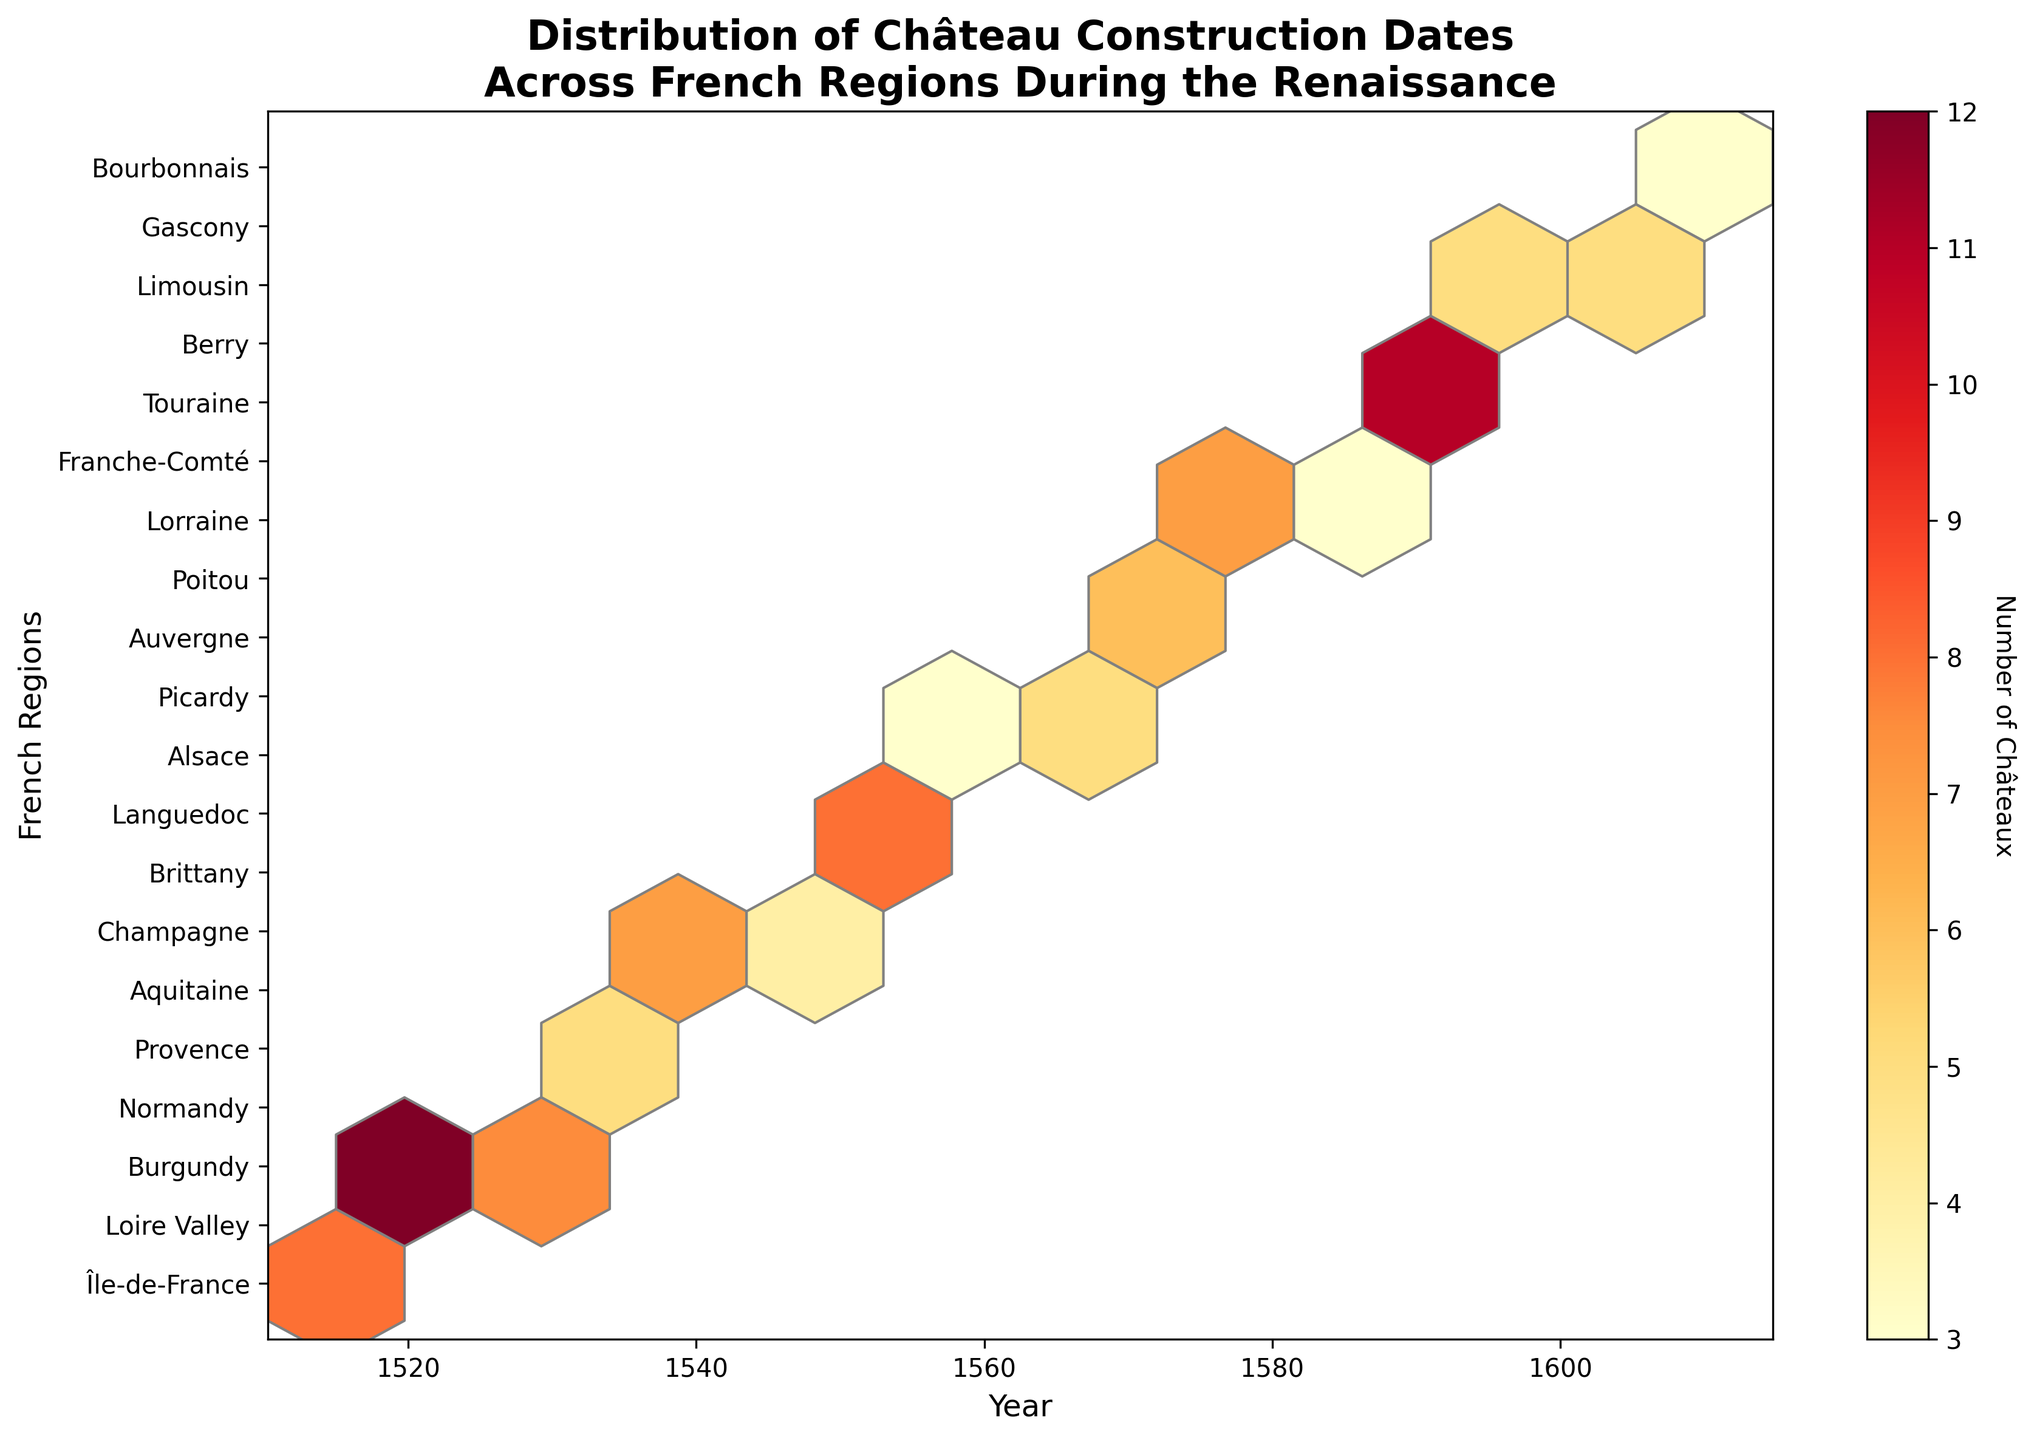What's the title of the figure? To read the title, look at the top of the plot where the text is usually displayed. The title is: "Distribution of Château Construction Dates Across French Regions During the Renaissance".
Answer: Distribution of Château Construction Dates Across French Regions During the Renaissance What are the x-axis and y-axis labels? The x-axis label shows the measurement being observed over time, while the y-axis label shows individual regions. According to the figure, the x-axis is labeled "Year" and the y-axis is labeled "French Regions".
Answer: Year, French Regions Which region shows the highest number of châteaux constructions? To find this, observe the color intensity and area of the hexagons. The Loire Valley region has the most intense color.
Answer: Loire Valley Which region shows the least number of châteaux constructions? The region with the faintest color and smallest area of hexagons would represent the least number of constructions. According to the colors, Alsace shows the least constructions.
Answer: Alsace In which time period was château construction most frequent? By identifying the time period with the most numerous and colorful hexagons, we see that the period between 1520 and 1590 has the highest frequency.
Answer: 1520-1590 How many regions are represented in the plot? To determine this, count the number of y-axis tick labels that represent different regions. There are 20 unique regions listed.
Answer: 20 Compare the number of châteaux constructed in Île-de-France and Brittany. Which is higher? Look at the color and size of the corresponding hexagons for both regions. Île-de-France has a slightly less intense color than Brittany.
Answer: Brittany During which time period does Poitou show an increase in château construction? Observe the hexagons for Poitou over time, noting periods where the color becomes more intense. Poitou shows an increase around 1575.
Answer: Around 1575 What color represents the highest number of châteaux constructions? The hexbin plot uses a color gradient, where more intense colors indicate higher values. The highest number is represented by deep red.
Answer: Deep red 